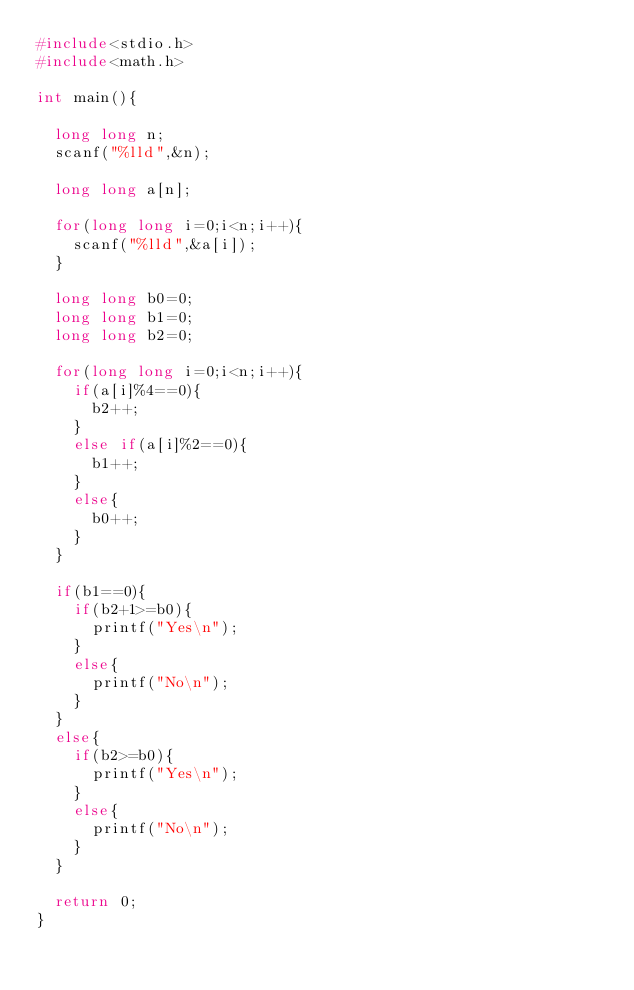<code> <loc_0><loc_0><loc_500><loc_500><_C_>#include<stdio.h>
#include<math.h>

int main(){

  long long n;
  scanf("%lld",&n);

  long long a[n];

  for(long long i=0;i<n;i++){
    scanf("%lld",&a[i]);
  }

  long long b0=0;
  long long b1=0;
  long long b2=0;

  for(long long i=0;i<n;i++){
    if(a[i]%4==0){
      b2++;
    }
    else if(a[i]%2==0){
      b1++;
    }
    else{
      b0++;
    }
  }

  if(b1==0){
    if(b2+1>=b0){
      printf("Yes\n");
    }
    else{
      printf("No\n");
    }
  }
  else{
    if(b2>=b0){
      printf("Yes\n");
    }
    else{
      printf("No\n");
    }
  }

  return 0;
}
</code> 